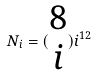Convert formula to latex. <formula><loc_0><loc_0><loc_500><loc_500>N _ { i } = ( \begin{matrix} 8 \\ i \end{matrix} ) i ^ { 1 2 }</formula> 